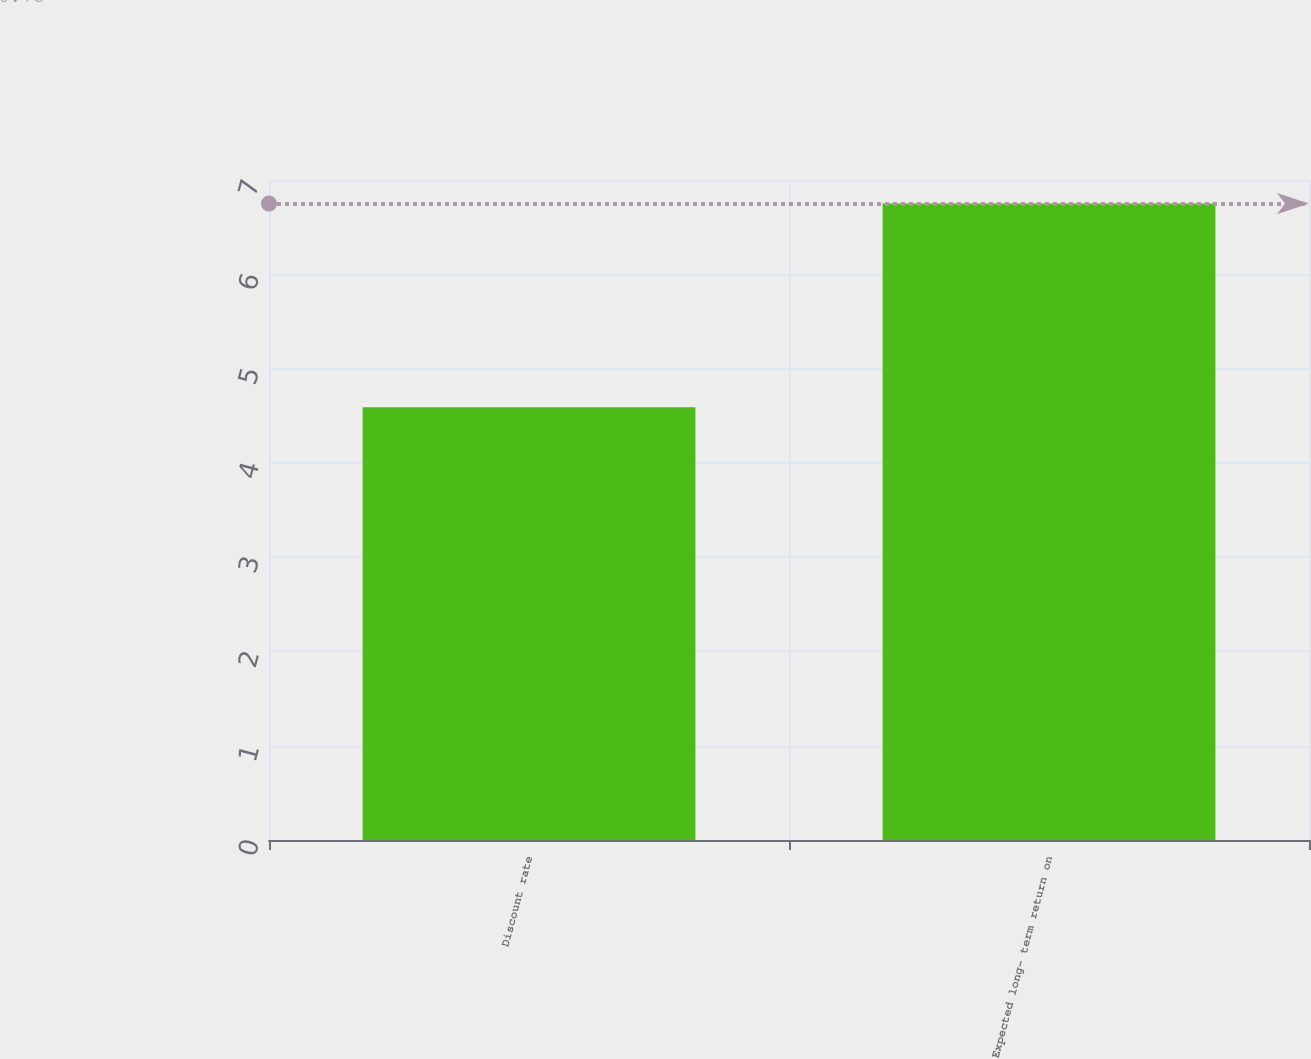Convert chart to OTSL. <chart><loc_0><loc_0><loc_500><loc_500><bar_chart><fcel>Discount rate<fcel>Expected long- term return on<nl><fcel>4.59<fcel>6.75<nl></chart> 